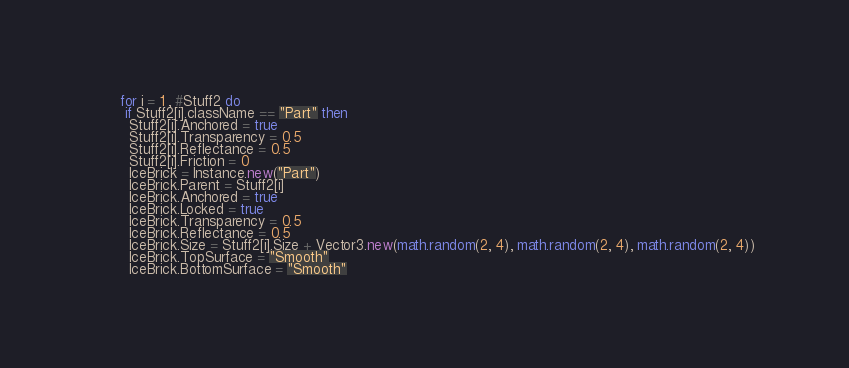Convert code to text. <code><loc_0><loc_0><loc_500><loc_500><_Lua_>      for i = 1 , #Stuff2 do
       if Stuff2[i].className == "Part" then
        Stuff2[i].Anchored = true
        Stuff2[i].Transparency = 0.5
        Stuff2[i].Reflectance = 0.5
        Stuff2[i].Friction = 0
        IceBrick = Instance.new("Part")
        IceBrick.Parent = Stuff2[i]
        IceBrick.Anchored = true
        IceBrick.Locked = true
        IceBrick.Transparency = 0.5
        IceBrick.Reflectance = 0.5
        IceBrick.Size = Stuff2[i].Size + Vector3.new(math.random(2, 4), math.random(2, 4), math.random(2, 4))
        IceBrick.TopSurface = "Smooth"
        IceBrick.BottomSurface = "Smooth"</code> 